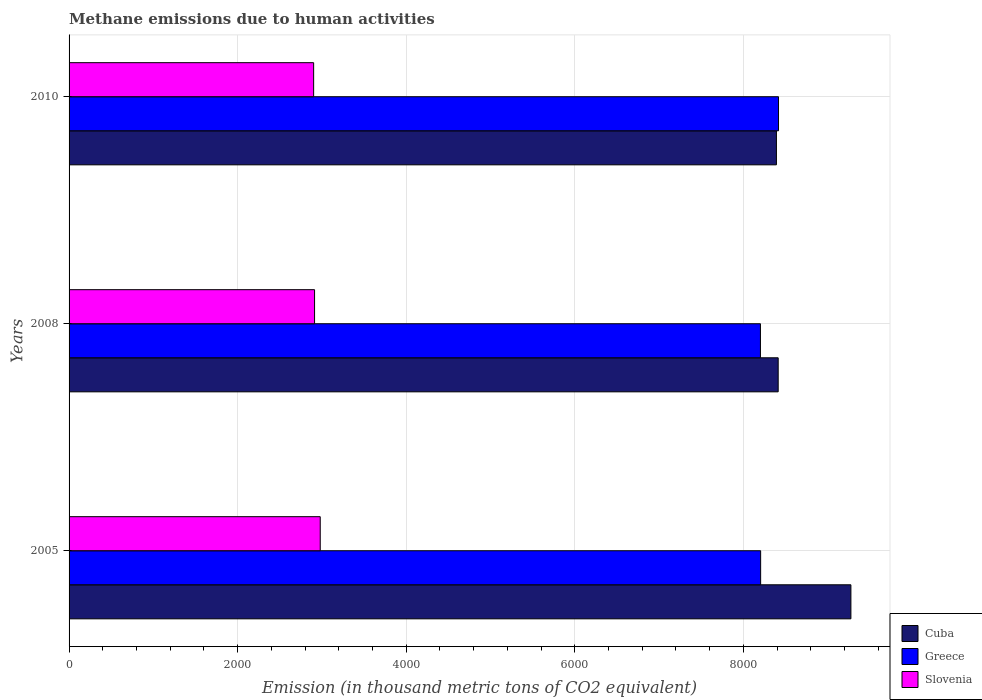How many groups of bars are there?
Offer a terse response. 3. Are the number of bars per tick equal to the number of legend labels?
Provide a short and direct response. Yes. How many bars are there on the 1st tick from the top?
Give a very brief answer. 3. How many bars are there on the 3rd tick from the bottom?
Your answer should be compact. 3. What is the label of the 3rd group of bars from the top?
Provide a succinct answer. 2005. In how many cases, is the number of bars for a given year not equal to the number of legend labels?
Provide a short and direct response. 0. What is the amount of methane emitted in Slovenia in 2010?
Provide a short and direct response. 2901.7. Across all years, what is the maximum amount of methane emitted in Cuba?
Ensure brevity in your answer.  9275.8. Across all years, what is the minimum amount of methane emitted in Cuba?
Offer a very short reply. 8392.1. What is the total amount of methane emitted in Slovenia in the graph?
Make the answer very short. 8794.1. What is the difference between the amount of methane emitted in Slovenia in 2005 and that in 2010?
Keep it short and to the point. 78.2. What is the difference between the amount of methane emitted in Cuba in 2010 and the amount of methane emitted in Greece in 2005?
Offer a very short reply. 187.2. What is the average amount of methane emitted in Cuba per year?
Your response must be concise. 8693.67. In the year 2010, what is the difference between the amount of methane emitted in Greece and amount of methane emitted in Slovenia?
Offer a terse response. 5515.3. What is the ratio of the amount of methane emitted in Cuba in 2008 to that in 2010?
Your answer should be very brief. 1. Is the difference between the amount of methane emitted in Greece in 2008 and 2010 greater than the difference between the amount of methane emitted in Slovenia in 2008 and 2010?
Give a very brief answer. No. What is the difference between the highest and the second highest amount of methane emitted in Cuba?
Keep it short and to the point. 862.7. What is the difference between the highest and the lowest amount of methane emitted in Cuba?
Provide a short and direct response. 883.7. In how many years, is the amount of methane emitted in Greece greater than the average amount of methane emitted in Greece taken over all years?
Keep it short and to the point. 1. Is the sum of the amount of methane emitted in Cuba in 2005 and 2008 greater than the maximum amount of methane emitted in Slovenia across all years?
Offer a very short reply. Yes. What does the 3rd bar from the top in 2005 represents?
Provide a succinct answer. Cuba. What does the 2nd bar from the bottom in 2008 represents?
Your response must be concise. Greece. How many bars are there?
Your response must be concise. 9. Are all the bars in the graph horizontal?
Provide a succinct answer. Yes. What is the difference between two consecutive major ticks on the X-axis?
Make the answer very short. 2000. Does the graph contain grids?
Keep it short and to the point. Yes. What is the title of the graph?
Make the answer very short. Methane emissions due to human activities. What is the label or title of the X-axis?
Your answer should be compact. Emission (in thousand metric tons of CO2 equivalent). What is the Emission (in thousand metric tons of CO2 equivalent) of Cuba in 2005?
Give a very brief answer. 9275.8. What is the Emission (in thousand metric tons of CO2 equivalent) in Greece in 2005?
Your answer should be compact. 8204.9. What is the Emission (in thousand metric tons of CO2 equivalent) in Slovenia in 2005?
Your answer should be compact. 2979.9. What is the Emission (in thousand metric tons of CO2 equivalent) in Cuba in 2008?
Provide a short and direct response. 8413.1. What is the Emission (in thousand metric tons of CO2 equivalent) in Greece in 2008?
Your answer should be compact. 8202.6. What is the Emission (in thousand metric tons of CO2 equivalent) of Slovenia in 2008?
Offer a very short reply. 2912.5. What is the Emission (in thousand metric tons of CO2 equivalent) of Cuba in 2010?
Your answer should be very brief. 8392.1. What is the Emission (in thousand metric tons of CO2 equivalent) in Greece in 2010?
Make the answer very short. 8417. What is the Emission (in thousand metric tons of CO2 equivalent) in Slovenia in 2010?
Your response must be concise. 2901.7. Across all years, what is the maximum Emission (in thousand metric tons of CO2 equivalent) in Cuba?
Your answer should be compact. 9275.8. Across all years, what is the maximum Emission (in thousand metric tons of CO2 equivalent) in Greece?
Provide a short and direct response. 8417. Across all years, what is the maximum Emission (in thousand metric tons of CO2 equivalent) of Slovenia?
Offer a terse response. 2979.9. Across all years, what is the minimum Emission (in thousand metric tons of CO2 equivalent) of Cuba?
Offer a very short reply. 8392.1. Across all years, what is the minimum Emission (in thousand metric tons of CO2 equivalent) in Greece?
Your response must be concise. 8202.6. Across all years, what is the minimum Emission (in thousand metric tons of CO2 equivalent) of Slovenia?
Provide a succinct answer. 2901.7. What is the total Emission (in thousand metric tons of CO2 equivalent) in Cuba in the graph?
Your answer should be compact. 2.61e+04. What is the total Emission (in thousand metric tons of CO2 equivalent) in Greece in the graph?
Your answer should be compact. 2.48e+04. What is the total Emission (in thousand metric tons of CO2 equivalent) of Slovenia in the graph?
Provide a succinct answer. 8794.1. What is the difference between the Emission (in thousand metric tons of CO2 equivalent) of Cuba in 2005 and that in 2008?
Provide a succinct answer. 862.7. What is the difference between the Emission (in thousand metric tons of CO2 equivalent) in Slovenia in 2005 and that in 2008?
Your response must be concise. 67.4. What is the difference between the Emission (in thousand metric tons of CO2 equivalent) in Cuba in 2005 and that in 2010?
Ensure brevity in your answer.  883.7. What is the difference between the Emission (in thousand metric tons of CO2 equivalent) of Greece in 2005 and that in 2010?
Offer a very short reply. -212.1. What is the difference between the Emission (in thousand metric tons of CO2 equivalent) of Slovenia in 2005 and that in 2010?
Offer a very short reply. 78.2. What is the difference between the Emission (in thousand metric tons of CO2 equivalent) in Greece in 2008 and that in 2010?
Provide a succinct answer. -214.4. What is the difference between the Emission (in thousand metric tons of CO2 equivalent) of Cuba in 2005 and the Emission (in thousand metric tons of CO2 equivalent) of Greece in 2008?
Ensure brevity in your answer.  1073.2. What is the difference between the Emission (in thousand metric tons of CO2 equivalent) of Cuba in 2005 and the Emission (in thousand metric tons of CO2 equivalent) of Slovenia in 2008?
Provide a short and direct response. 6363.3. What is the difference between the Emission (in thousand metric tons of CO2 equivalent) in Greece in 2005 and the Emission (in thousand metric tons of CO2 equivalent) in Slovenia in 2008?
Your answer should be compact. 5292.4. What is the difference between the Emission (in thousand metric tons of CO2 equivalent) in Cuba in 2005 and the Emission (in thousand metric tons of CO2 equivalent) in Greece in 2010?
Ensure brevity in your answer.  858.8. What is the difference between the Emission (in thousand metric tons of CO2 equivalent) of Cuba in 2005 and the Emission (in thousand metric tons of CO2 equivalent) of Slovenia in 2010?
Your answer should be compact. 6374.1. What is the difference between the Emission (in thousand metric tons of CO2 equivalent) in Greece in 2005 and the Emission (in thousand metric tons of CO2 equivalent) in Slovenia in 2010?
Provide a succinct answer. 5303.2. What is the difference between the Emission (in thousand metric tons of CO2 equivalent) in Cuba in 2008 and the Emission (in thousand metric tons of CO2 equivalent) in Slovenia in 2010?
Provide a short and direct response. 5511.4. What is the difference between the Emission (in thousand metric tons of CO2 equivalent) of Greece in 2008 and the Emission (in thousand metric tons of CO2 equivalent) of Slovenia in 2010?
Give a very brief answer. 5300.9. What is the average Emission (in thousand metric tons of CO2 equivalent) in Cuba per year?
Provide a short and direct response. 8693.67. What is the average Emission (in thousand metric tons of CO2 equivalent) of Greece per year?
Provide a succinct answer. 8274.83. What is the average Emission (in thousand metric tons of CO2 equivalent) of Slovenia per year?
Keep it short and to the point. 2931.37. In the year 2005, what is the difference between the Emission (in thousand metric tons of CO2 equivalent) of Cuba and Emission (in thousand metric tons of CO2 equivalent) of Greece?
Keep it short and to the point. 1070.9. In the year 2005, what is the difference between the Emission (in thousand metric tons of CO2 equivalent) of Cuba and Emission (in thousand metric tons of CO2 equivalent) of Slovenia?
Provide a short and direct response. 6295.9. In the year 2005, what is the difference between the Emission (in thousand metric tons of CO2 equivalent) of Greece and Emission (in thousand metric tons of CO2 equivalent) of Slovenia?
Ensure brevity in your answer.  5225. In the year 2008, what is the difference between the Emission (in thousand metric tons of CO2 equivalent) in Cuba and Emission (in thousand metric tons of CO2 equivalent) in Greece?
Ensure brevity in your answer.  210.5. In the year 2008, what is the difference between the Emission (in thousand metric tons of CO2 equivalent) in Cuba and Emission (in thousand metric tons of CO2 equivalent) in Slovenia?
Your answer should be compact. 5500.6. In the year 2008, what is the difference between the Emission (in thousand metric tons of CO2 equivalent) of Greece and Emission (in thousand metric tons of CO2 equivalent) of Slovenia?
Your answer should be very brief. 5290.1. In the year 2010, what is the difference between the Emission (in thousand metric tons of CO2 equivalent) in Cuba and Emission (in thousand metric tons of CO2 equivalent) in Greece?
Make the answer very short. -24.9. In the year 2010, what is the difference between the Emission (in thousand metric tons of CO2 equivalent) in Cuba and Emission (in thousand metric tons of CO2 equivalent) in Slovenia?
Offer a terse response. 5490.4. In the year 2010, what is the difference between the Emission (in thousand metric tons of CO2 equivalent) of Greece and Emission (in thousand metric tons of CO2 equivalent) of Slovenia?
Provide a succinct answer. 5515.3. What is the ratio of the Emission (in thousand metric tons of CO2 equivalent) of Cuba in 2005 to that in 2008?
Give a very brief answer. 1.1. What is the ratio of the Emission (in thousand metric tons of CO2 equivalent) in Slovenia in 2005 to that in 2008?
Your answer should be very brief. 1.02. What is the ratio of the Emission (in thousand metric tons of CO2 equivalent) in Cuba in 2005 to that in 2010?
Your response must be concise. 1.11. What is the ratio of the Emission (in thousand metric tons of CO2 equivalent) of Greece in 2005 to that in 2010?
Offer a terse response. 0.97. What is the ratio of the Emission (in thousand metric tons of CO2 equivalent) of Slovenia in 2005 to that in 2010?
Offer a terse response. 1.03. What is the ratio of the Emission (in thousand metric tons of CO2 equivalent) in Cuba in 2008 to that in 2010?
Your answer should be compact. 1. What is the ratio of the Emission (in thousand metric tons of CO2 equivalent) in Greece in 2008 to that in 2010?
Your answer should be compact. 0.97. What is the ratio of the Emission (in thousand metric tons of CO2 equivalent) of Slovenia in 2008 to that in 2010?
Offer a very short reply. 1. What is the difference between the highest and the second highest Emission (in thousand metric tons of CO2 equivalent) of Cuba?
Keep it short and to the point. 862.7. What is the difference between the highest and the second highest Emission (in thousand metric tons of CO2 equivalent) of Greece?
Provide a succinct answer. 212.1. What is the difference between the highest and the second highest Emission (in thousand metric tons of CO2 equivalent) in Slovenia?
Offer a very short reply. 67.4. What is the difference between the highest and the lowest Emission (in thousand metric tons of CO2 equivalent) of Cuba?
Your answer should be compact. 883.7. What is the difference between the highest and the lowest Emission (in thousand metric tons of CO2 equivalent) of Greece?
Offer a terse response. 214.4. What is the difference between the highest and the lowest Emission (in thousand metric tons of CO2 equivalent) in Slovenia?
Offer a terse response. 78.2. 